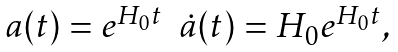<formula> <loc_0><loc_0><loc_500><loc_500>\begin{array} { l c r } a ( t ) = e ^ { H _ { 0 } t } & \dot { a } ( t ) = H _ { 0 } e ^ { H _ { 0 } t } , \\ \end{array}</formula> 